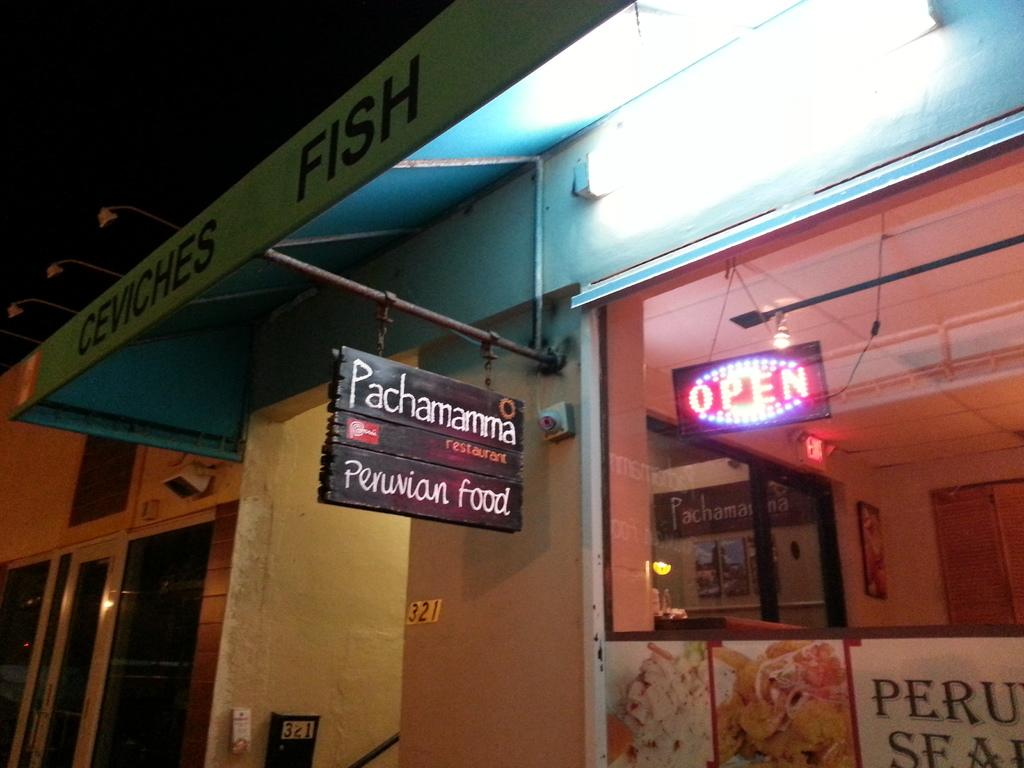Provide a one-sentence caption for the provided image. A neon open sign in the window of a Peruvian Restaurant. 